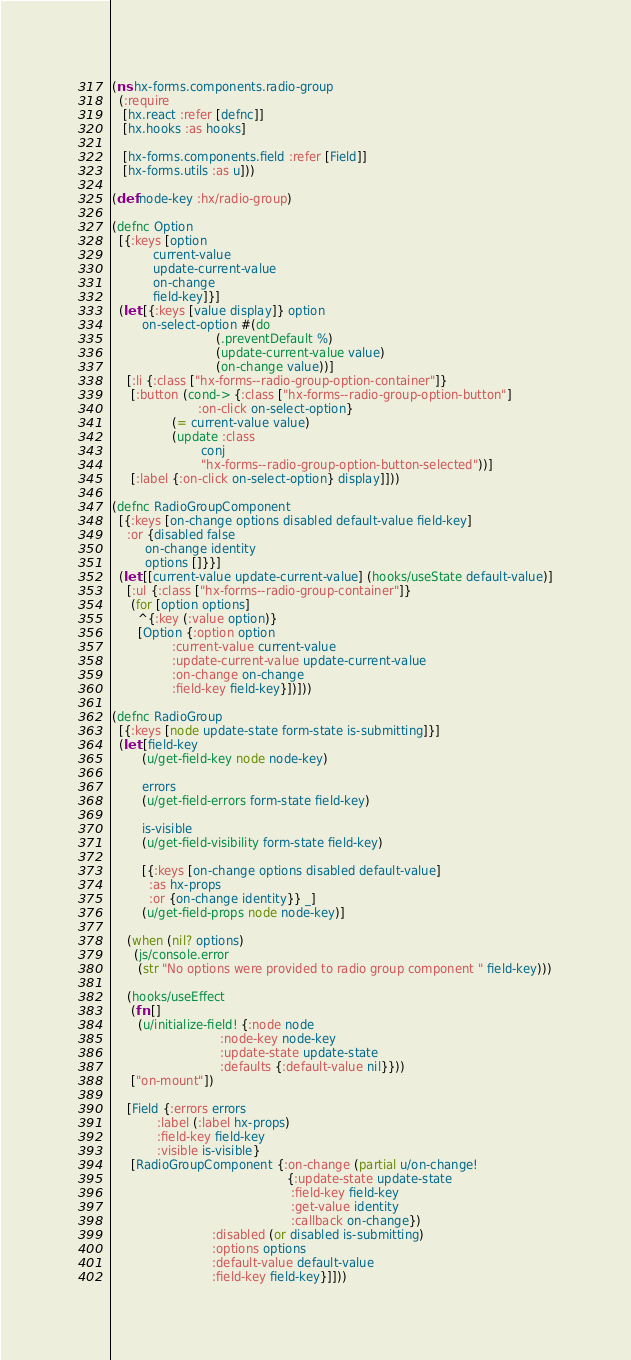<code> <loc_0><loc_0><loc_500><loc_500><_Clojure_>(ns hx-forms.components.radio-group
  (:require
   [hx.react :refer [defnc]]
   [hx.hooks :as hooks]

   [hx-forms.components.field :refer [Field]]
   [hx-forms.utils :as u]))

(def node-key :hx/radio-group)

(defnc Option
  [{:keys [option
           current-value
           update-current-value
           on-change
           field-key]}]
  (let [{:keys [value display]} option
        on-select-option #(do
                            (.preventDefault %)
                            (update-current-value value)
                            (on-change value))]
    [:li {:class ["hx-forms--radio-group-option-container"]}
     [:button (cond-> {:class ["hx-forms--radio-group-option-button"]
                       :on-click on-select-option}
                (= current-value value)
                (update :class
                        conj
                        "hx-forms--radio-group-option-button-selected"))]
     [:label {:on-click on-select-option} display]]))

(defnc RadioGroupComponent
  [{:keys [on-change options disabled default-value field-key]
    :or {disabled false
         on-change identity
         options []}}]
  (let [[current-value update-current-value] (hooks/useState default-value)]
    [:ul {:class ["hx-forms--radio-group-container"]}
     (for [option options]
       ^{:key (:value option)}
       [Option {:option option
                :current-value current-value
                :update-current-value update-current-value
                :on-change on-change
                :field-key field-key}])]))

(defnc RadioGroup
  [{:keys [node update-state form-state is-submitting]}]
  (let [field-key
        (u/get-field-key node node-key)

        errors
        (u/get-field-errors form-state field-key)

        is-visible
        (u/get-field-visibility form-state field-key)

        [{:keys [on-change options disabled default-value]
          :as hx-props
          :or {on-change identity}} _]
        (u/get-field-props node node-key)]

    (when (nil? options)
      (js/console.error
       (str "No options were provided to radio group component " field-key)))

    (hooks/useEffect
     (fn []
       (u/initialize-field! {:node node
                             :node-key node-key
                             :update-state update-state
                             :defaults {:default-value nil}}))
     ["on-mount"])

    [Field {:errors errors
            :label (:label hx-props)
            :field-key field-key
            :visible is-visible}
     [RadioGroupComponent {:on-change (partial u/on-change!
                                               {:update-state update-state
                                                :field-key field-key
                                                :get-value identity
                                                :callback on-change})
                           :disabled (or disabled is-submitting)
                           :options options
                           :default-value default-value
                           :field-key field-key}]]))
</code> 